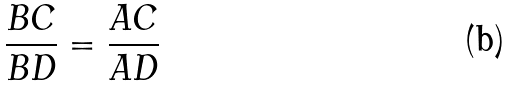Convert formula to latex. <formula><loc_0><loc_0><loc_500><loc_500>\frac { B C } { B D } = \frac { A C } { A D }</formula> 